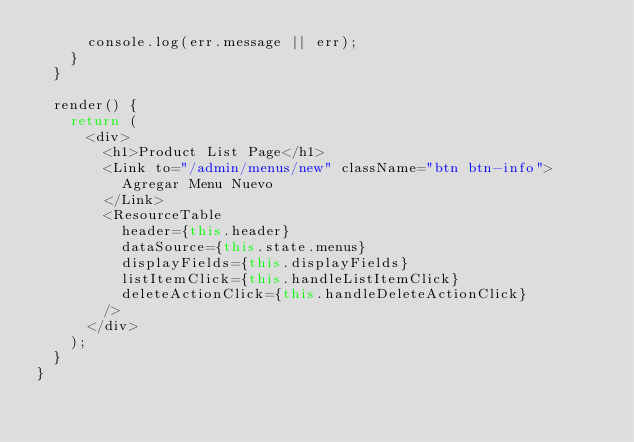<code> <loc_0><loc_0><loc_500><loc_500><_JavaScript_>			console.log(err.message || err);
		}
	}

	render() {
		return (
			<div>
				<h1>Product List Page</h1>
				<Link to="/admin/menus/new" className="btn btn-info">
					Agregar Menu Nuevo
				</Link>
				<ResourceTable
					header={this.header}
					dataSource={this.state.menus}
					displayFields={this.displayFields}
					listItemClick={this.handleListItemClick}
					deleteActionClick={this.handleDeleteActionClick}
				/>
			</div>
		);
	}
}
</code> 